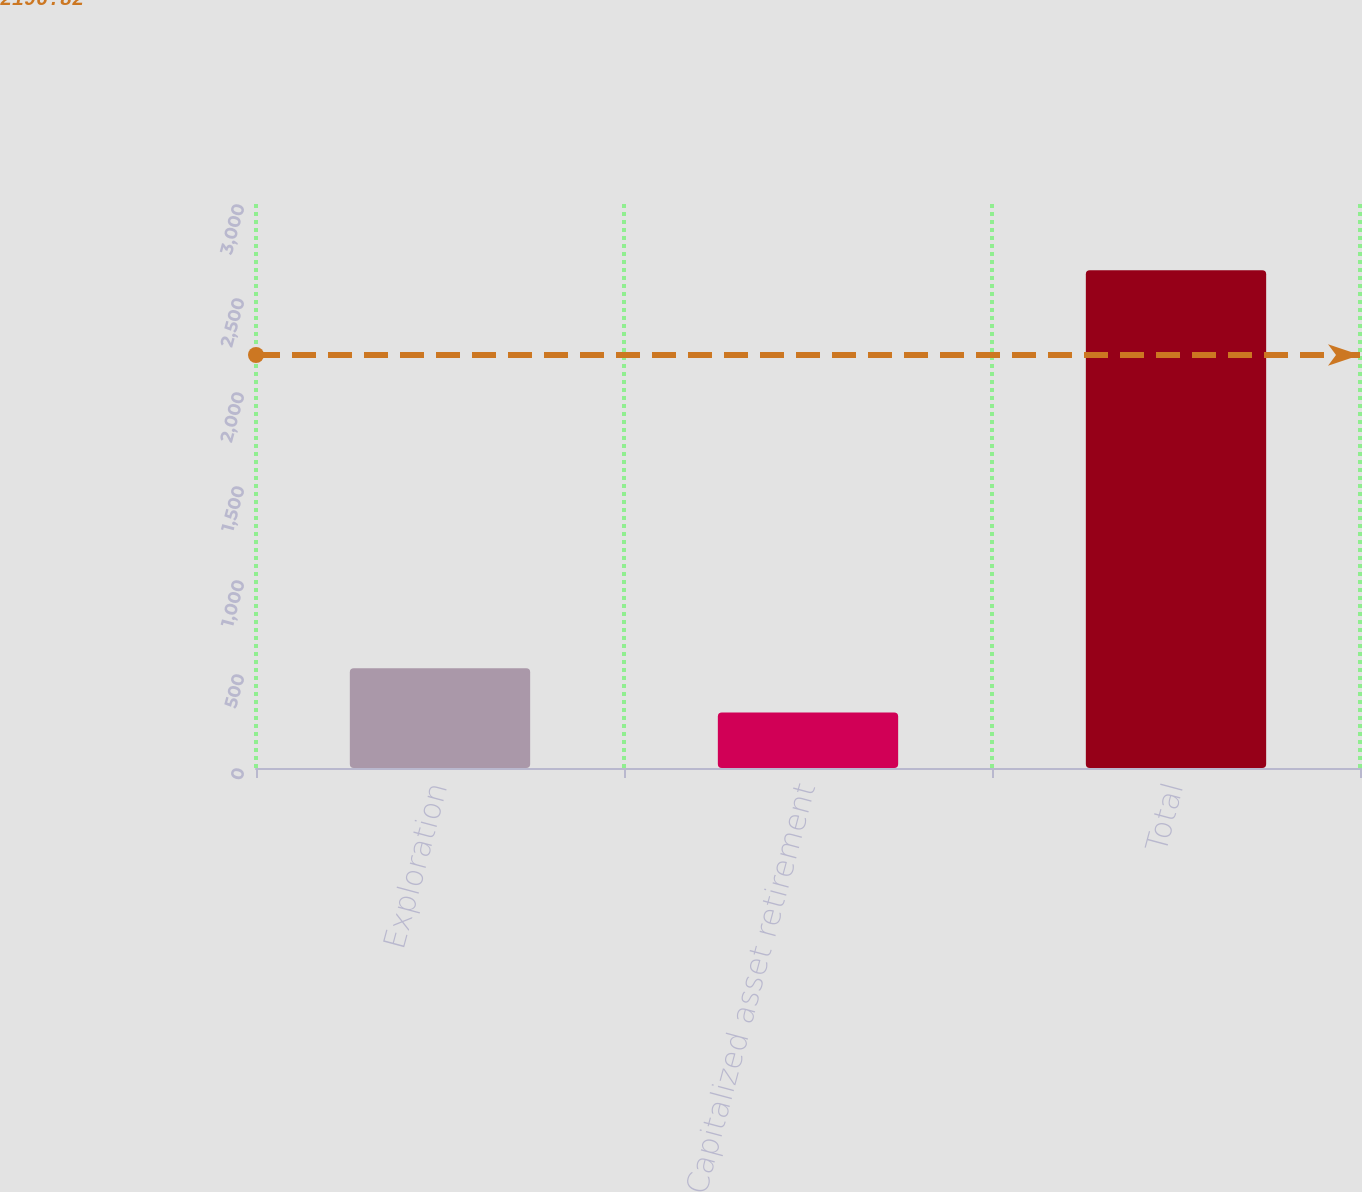<chart> <loc_0><loc_0><loc_500><loc_500><bar_chart><fcel>Exploration<fcel>Capitalized asset retirement<fcel>Total<nl><fcel>530.3<fcel>295<fcel>2648<nl></chart> 